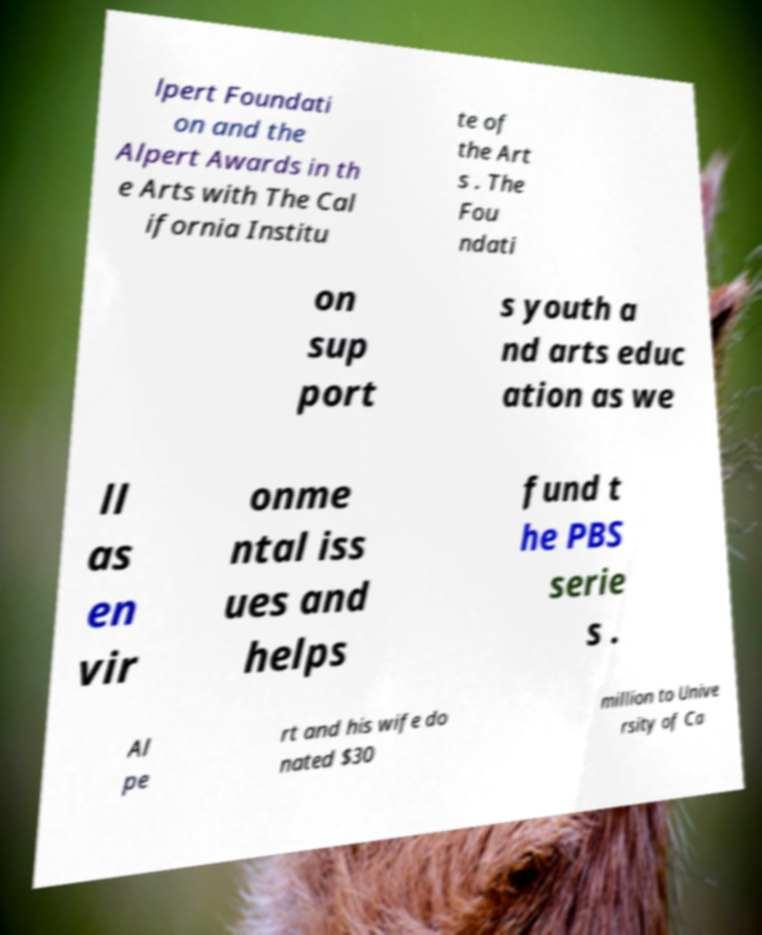Please read and relay the text visible in this image. What does it say? lpert Foundati on and the Alpert Awards in th e Arts with The Cal ifornia Institu te of the Art s . The Fou ndati on sup port s youth a nd arts educ ation as we ll as en vir onme ntal iss ues and helps fund t he PBS serie s . Al pe rt and his wife do nated $30 million to Unive rsity of Ca 